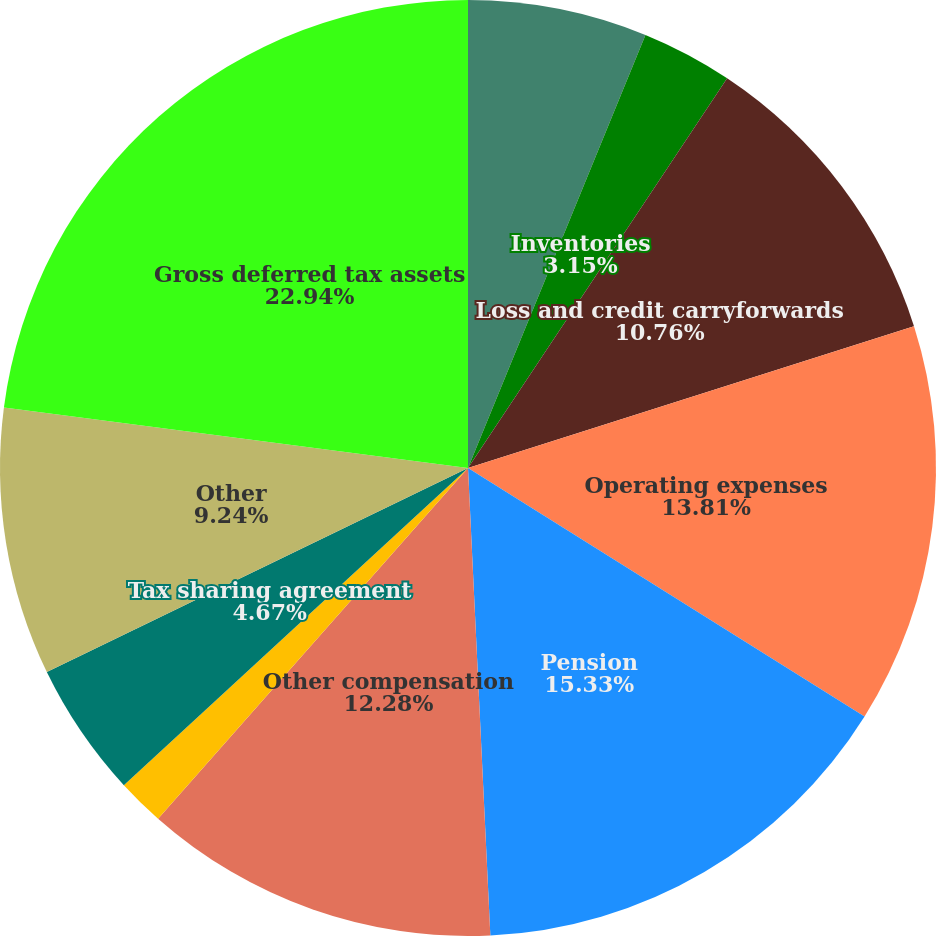Convert chart to OTSL. <chart><loc_0><loc_0><loc_500><loc_500><pie_chart><fcel>Accounts receivable<fcel>Inventories<fcel>Loss and credit carryforwards<fcel>Operating expenses<fcel>Pension<fcel>Other compensation<fcel>Postretirement benefits<fcel>Tax sharing agreement<fcel>Other<fcel>Gross deferred tax assets<nl><fcel>6.19%<fcel>3.15%<fcel>10.76%<fcel>13.81%<fcel>15.33%<fcel>12.28%<fcel>1.63%<fcel>4.67%<fcel>9.24%<fcel>22.94%<nl></chart> 